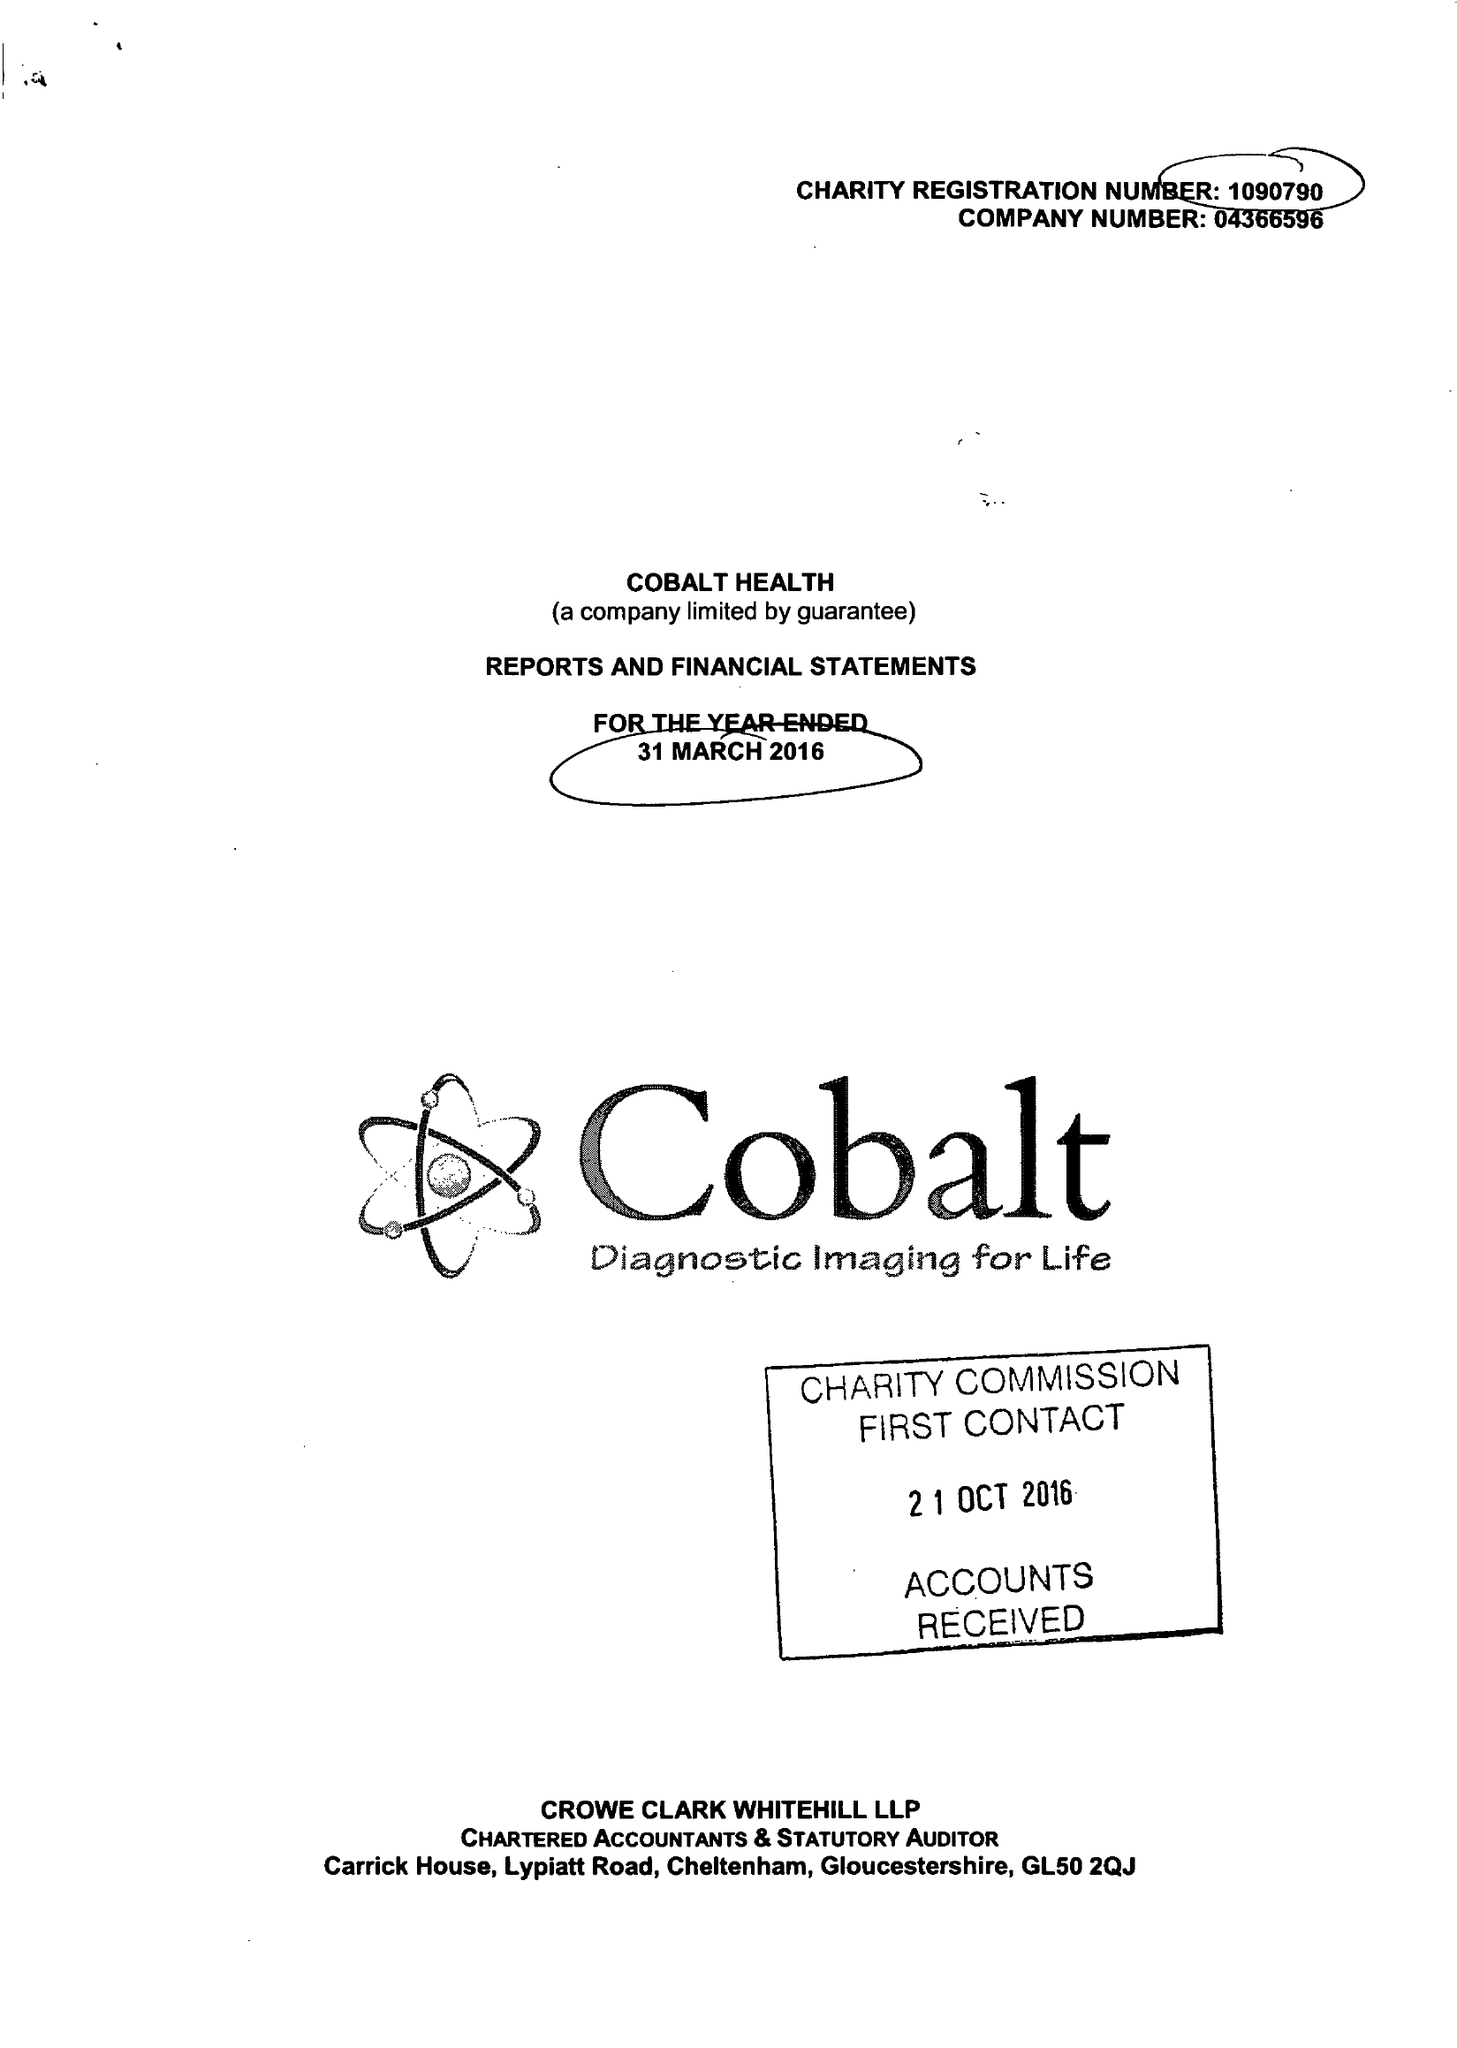What is the value for the charity_number?
Answer the question using a single word or phrase. 1090790 